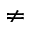<formula> <loc_0><loc_0><loc_500><loc_500>\ne</formula> 